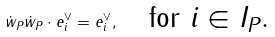Convert formula to latex. <formula><loc_0><loc_0><loc_500><loc_500>\dot { w } _ { P } \dot { w } _ { P } \cdot e ^ { \vee } _ { i } = e _ { i } ^ { \vee } , \quad \text {for $i\in I_{P}$.}</formula> 